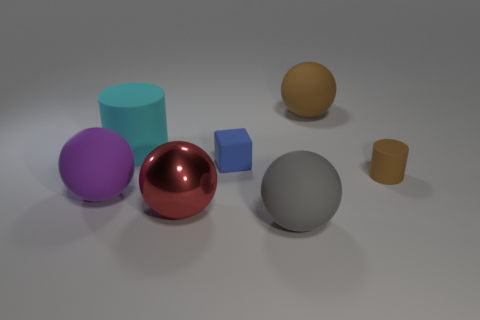What shape is the blue thing right of the big shiny object? The blue object located to the right of the large, reflective red sphere is a small cube. It appears to be solid and has a matte finish, contrasting with the smooth and shiny surface of the red sphere. 